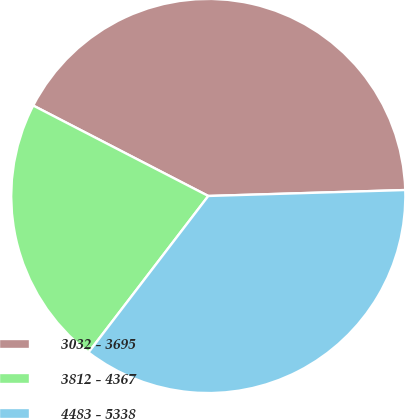Convert chart. <chart><loc_0><loc_0><loc_500><loc_500><pie_chart><fcel>3032 - 3695<fcel>3812 - 4367<fcel>4483 - 5338<nl><fcel>41.93%<fcel>22.19%<fcel>35.88%<nl></chart> 